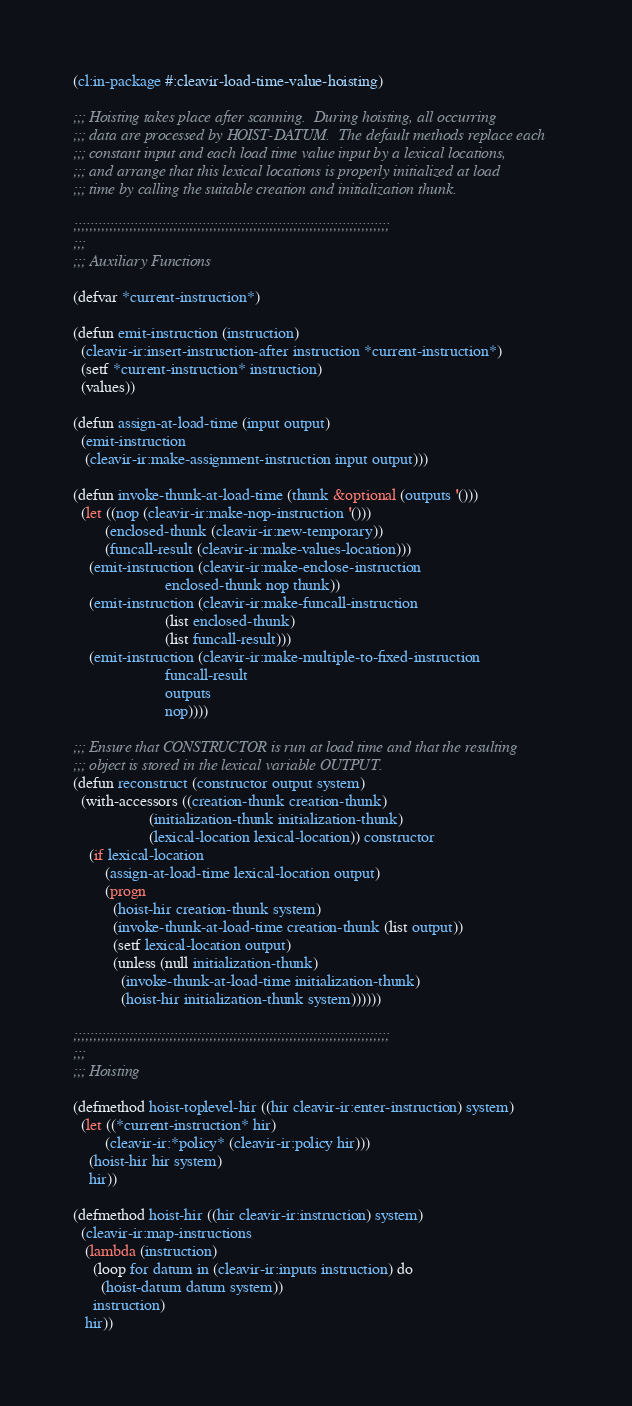Convert code to text. <code><loc_0><loc_0><loc_500><loc_500><_Lisp_>(cl:in-package #:cleavir-load-time-value-hoisting)

;;; Hoisting takes place after scanning.  During hoisting, all occurring
;;; data are processed by HOIST-DATUM.  The default methods replace each
;;; constant input and each load time value input by a lexical locations,
;;; and arrange that this lexical locations is properly initialized at load
;;; time by calling the suitable creation and initialization thunk.

;;;;;;;;;;;;;;;;;;;;;;;;;;;;;;;;;;;;;;;;;;;;;;;;;;;;;;;;;;;;;;;;;;;;;;;;;;;;;;;
;;;
;;; Auxiliary Functions

(defvar *current-instruction*)

(defun emit-instruction (instruction)
  (cleavir-ir:insert-instruction-after instruction *current-instruction*)
  (setf *current-instruction* instruction)
  (values))

(defun assign-at-load-time (input output)
  (emit-instruction
   (cleavir-ir:make-assignment-instruction input output)))

(defun invoke-thunk-at-load-time (thunk &optional (outputs '()))
  (let ((nop (cleavir-ir:make-nop-instruction '()))
        (enclosed-thunk (cleavir-ir:new-temporary))
        (funcall-result (cleavir-ir:make-values-location)))
    (emit-instruction (cleavir-ir:make-enclose-instruction
                       enclosed-thunk nop thunk))
    (emit-instruction (cleavir-ir:make-funcall-instruction
                       (list enclosed-thunk)
                       (list funcall-result)))
    (emit-instruction (cleavir-ir:make-multiple-to-fixed-instruction
                       funcall-result
                       outputs
                       nop))))

;;; Ensure that CONSTRUCTOR is run at load time and that the resulting
;;; object is stored in the lexical variable OUTPUT.
(defun reconstruct (constructor output system)
  (with-accessors ((creation-thunk creation-thunk)
                   (initialization-thunk initialization-thunk)
                   (lexical-location lexical-location)) constructor
    (if lexical-location
        (assign-at-load-time lexical-location output)
        (progn
          (hoist-hir creation-thunk system)
          (invoke-thunk-at-load-time creation-thunk (list output))
          (setf lexical-location output)
          (unless (null initialization-thunk)
            (invoke-thunk-at-load-time initialization-thunk)
            (hoist-hir initialization-thunk system))))))

;;;;;;;;;;;;;;;;;;;;;;;;;;;;;;;;;;;;;;;;;;;;;;;;;;;;;;;;;;;;;;;;;;;;;;;;;;;;;;;
;;;
;;; Hoisting

(defmethod hoist-toplevel-hir ((hir cleavir-ir:enter-instruction) system)
  (let ((*current-instruction* hir)
        (cleavir-ir:*policy* (cleavir-ir:policy hir)))
    (hoist-hir hir system)
    hir))

(defmethod hoist-hir ((hir cleavir-ir:instruction) system)
  (cleavir-ir:map-instructions
   (lambda (instruction)
     (loop for datum in (cleavir-ir:inputs instruction) do
       (hoist-datum datum system))
     instruction)
   hir))
</code> 